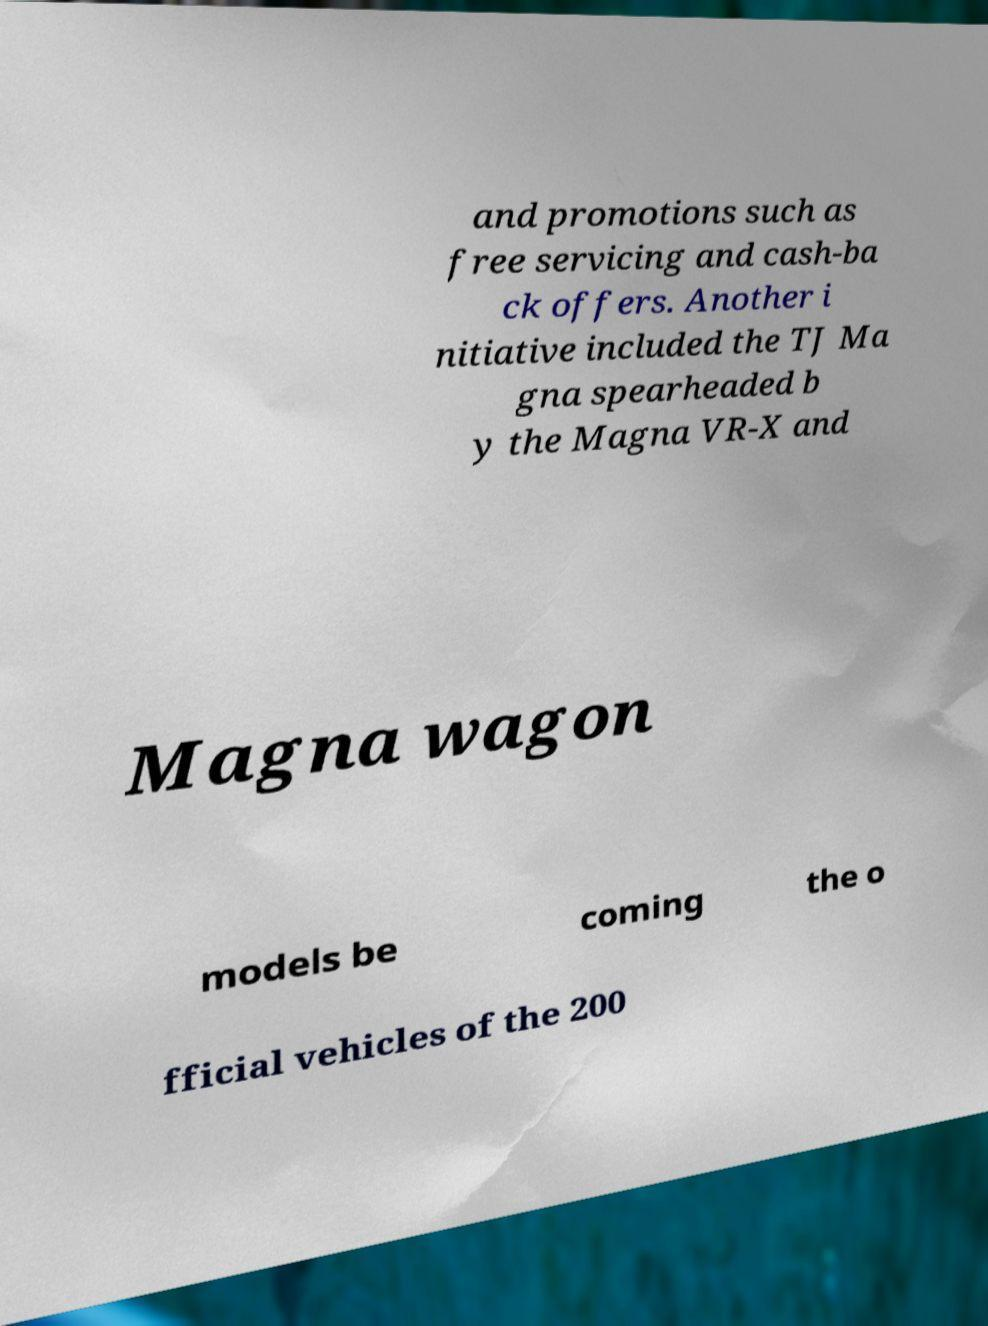There's text embedded in this image that I need extracted. Can you transcribe it verbatim? and promotions such as free servicing and cash-ba ck offers. Another i nitiative included the TJ Ma gna spearheaded b y the Magna VR-X and Magna wagon models be coming the o fficial vehicles of the 200 